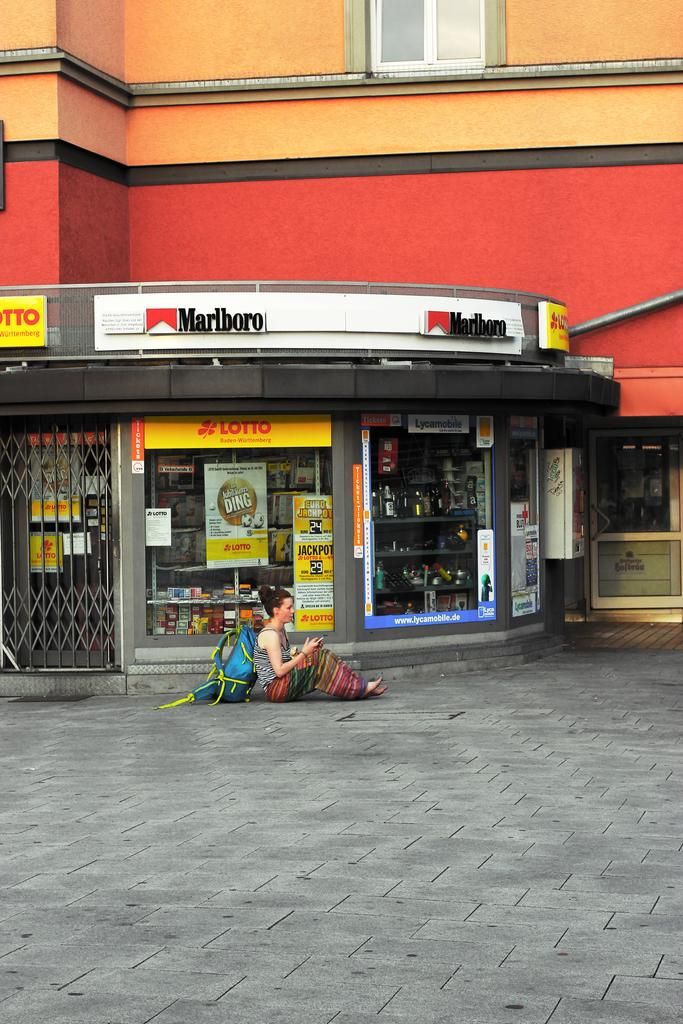<image>
Give a short and clear explanation of the subsequent image. A woman with a blue backpack sits on the ground outside of a store with a Lotto sign and a Marlboro sign. 